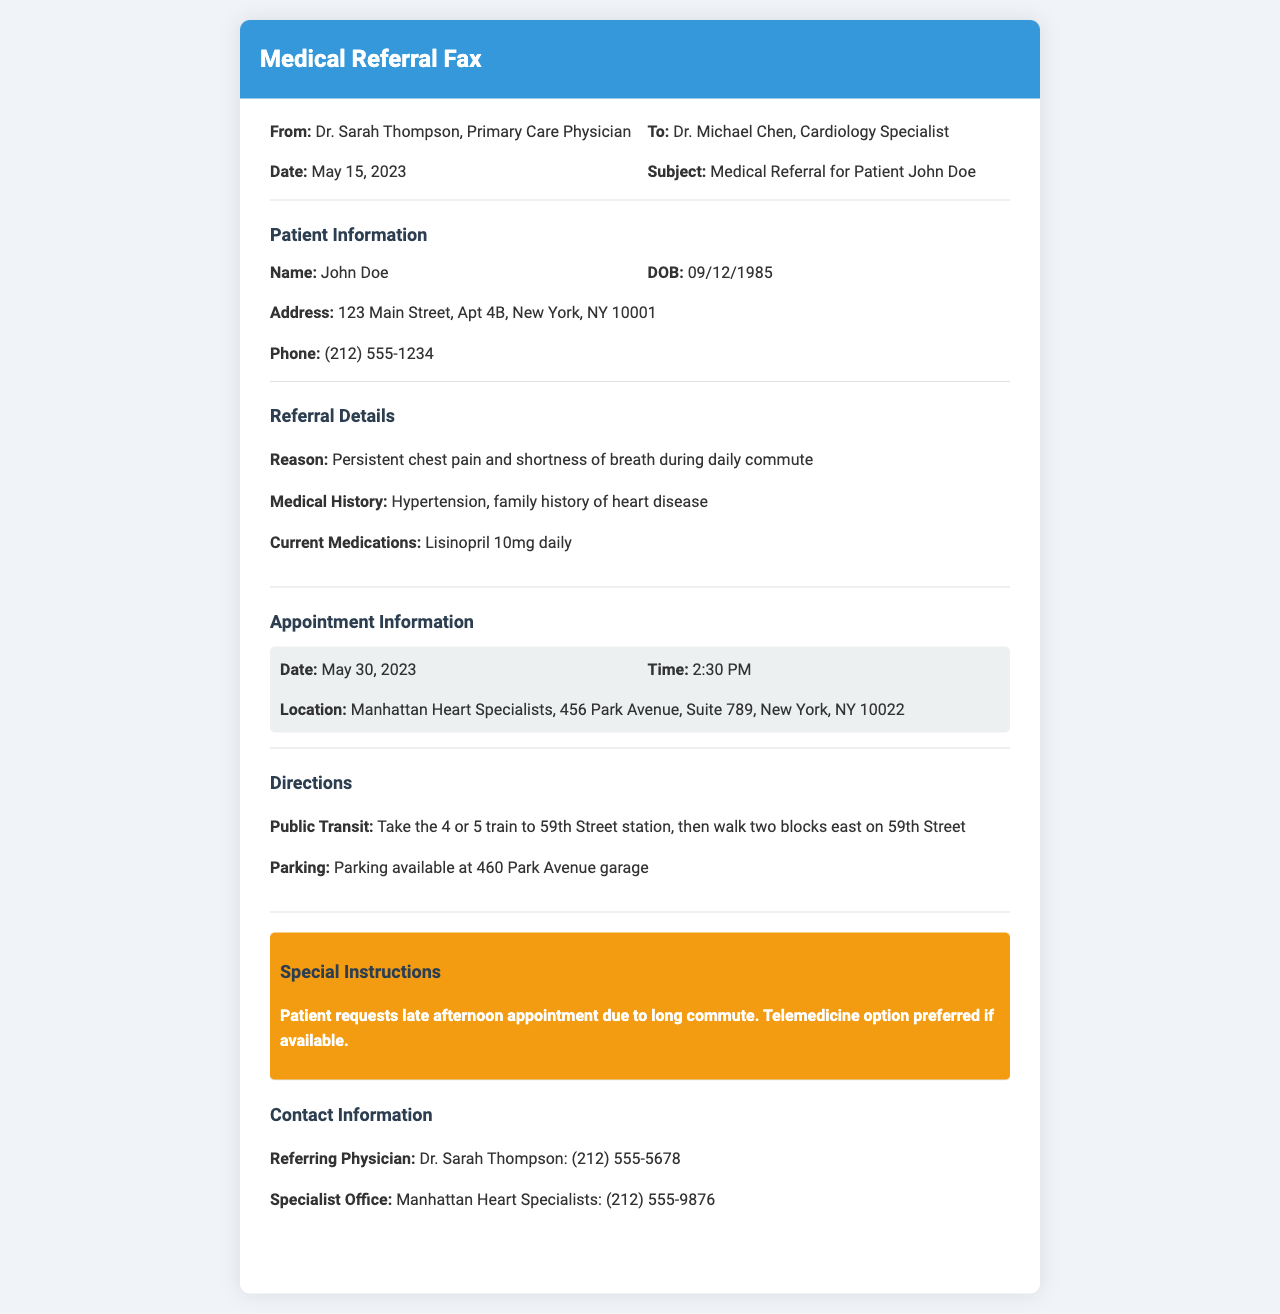What is the name of the referring physician? The name of the referring physician is stated as Dr. Sarah Thompson.
Answer: Dr. Sarah Thompson What is the appointment date? The appointment date for the specialist is specified in the document.
Answer: May 30, 2023 What is the location of the specialist's office? The office location is provided clearly in the appointment information section.
Answer: Manhattan Heart Specialists, 456 Park Avenue, Suite 789, New York, NY 10022 What is the reason for the referral? The referral reason is given in the referral details section.
Answer: Persistent chest pain and shortness of breath during daily commute What is the patient's date of birth? The patient's date of birth is indicated in the patient information section.
Answer: 09/12/1985 What type of appointment does the patient prefer? The patient's preference for the appointment type is mentioned in the special instructions section.
Answer: Telemedicine option preferred How can the patient reach the cardiology specialist's office? The directions for public transit and parking provide ways to reach the office.
Answer: Take the 4 or 5 train to 59th Street station What is the contact number of the referring physician? The contact number is provided in the contact information section of the document.
Answer: (212) 555-5678 What is the patient's phone number? The patient's phone number is specified in the patient information section.
Answer: (212) 555-1234 